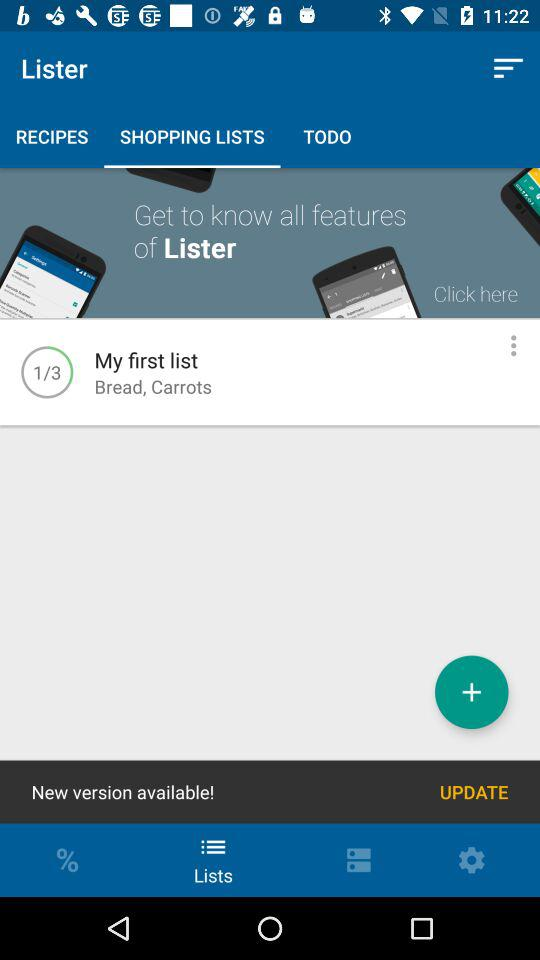Which tab am I on? You are on the tab "SHOPPING LISTS". 